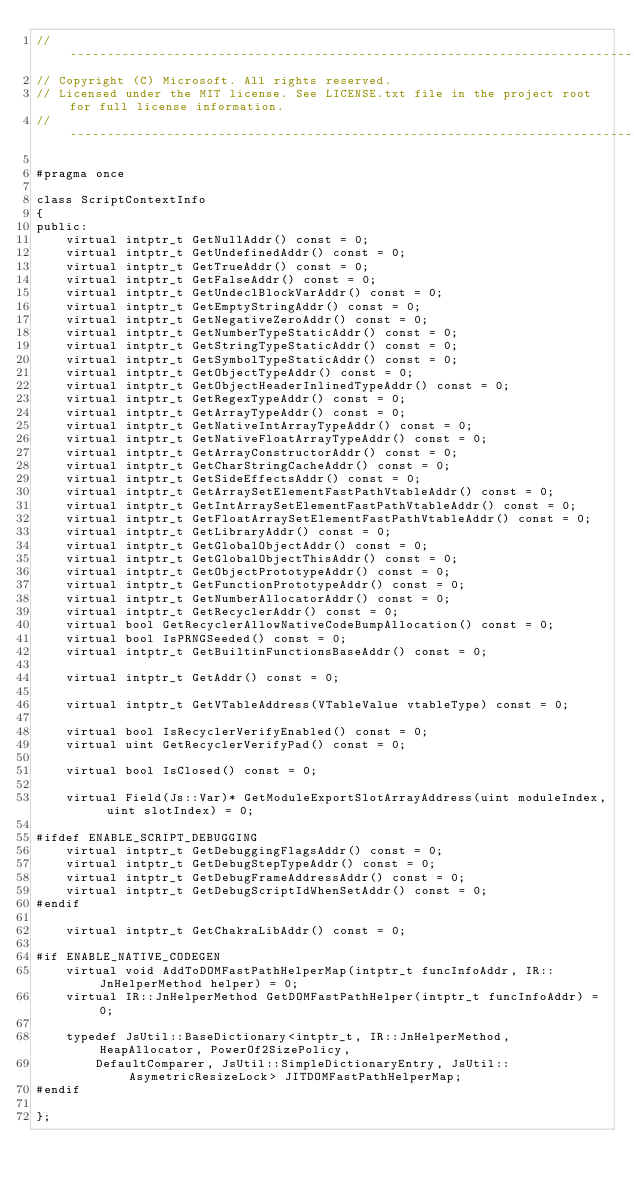Convert code to text. <code><loc_0><loc_0><loc_500><loc_500><_C_>//-------------------------------------------------------------------------------------------------------
// Copyright (C) Microsoft. All rights reserved.
// Licensed under the MIT license. See LICENSE.txt file in the project root for full license information.
//-------------------------------------------------------------------------------------------------------

#pragma once

class ScriptContextInfo
{
public:
    virtual intptr_t GetNullAddr() const = 0;
    virtual intptr_t GetUndefinedAddr() const = 0;
    virtual intptr_t GetTrueAddr() const = 0;
    virtual intptr_t GetFalseAddr() const = 0;
    virtual intptr_t GetUndeclBlockVarAddr() const = 0;
    virtual intptr_t GetEmptyStringAddr() const = 0;
    virtual intptr_t GetNegativeZeroAddr() const = 0;
    virtual intptr_t GetNumberTypeStaticAddr() const = 0;
    virtual intptr_t GetStringTypeStaticAddr() const = 0;
    virtual intptr_t GetSymbolTypeStaticAddr() const = 0;
    virtual intptr_t GetObjectTypeAddr() const = 0;
    virtual intptr_t GetObjectHeaderInlinedTypeAddr() const = 0;
    virtual intptr_t GetRegexTypeAddr() const = 0;
    virtual intptr_t GetArrayTypeAddr() const = 0;
    virtual intptr_t GetNativeIntArrayTypeAddr() const = 0;
    virtual intptr_t GetNativeFloatArrayTypeAddr() const = 0;
    virtual intptr_t GetArrayConstructorAddr() const = 0;
    virtual intptr_t GetCharStringCacheAddr() const = 0;
    virtual intptr_t GetSideEffectsAddr() const = 0;
    virtual intptr_t GetArraySetElementFastPathVtableAddr() const = 0;
    virtual intptr_t GetIntArraySetElementFastPathVtableAddr() const = 0;
    virtual intptr_t GetFloatArraySetElementFastPathVtableAddr() const = 0;
    virtual intptr_t GetLibraryAddr() const = 0;
    virtual intptr_t GetGlobalObjectAddr() const = 0;
    virtual intptr_t GetGlobalObjectThisAddr() const = 0;
    virtual intptr_t GetObjectPrototypeAddr() const = 0;
    virtual intptr_t GetFunctionPrototypeAddr() const = 0;
    virtual intptr_t GetNumberAllocatorAddr() const = 0;
    virtual intptr_t GetRecyclerAddr() const = 0;
    virtual bool GetRecyclerAllowNativeCodeBumpAllocation() const = 0;
    virtual bool IsPRNGSeeded() const = 0;
    virtual intptr_t GetBuiltinFunctionsBaseAddr() const = 0;

    virtual intptr_t GetAddr() const = 0;

    virtual intptr_t GetVTableAddress(VTableValue vtableType) const = 0;

    virtual bool IsRecyclerVerifyEnabled() const = 0;
    virtual uint GetRecyclerVerifyPad() const = 0;

    virtual bool IsClosed() const = 0;

    virtual Field(Js::Var)* GetModuleExportSlotArrayAddress(uint moduleIndex, uint slotIndex) = 0;

#ifdef ENABLE_SCRIPT_DEBUGGING
    virtual intptr_t GetDebuggingFlagsAddr() const = 0;
    virtual intptr_t GetDebugStepTypeAddr() const = 0;
    virtual intptr_t GetDebugFrameAddressAddr() const = 0;
    virtual intptr_t GetDebugScriptIdWhenSetAddr() const = 0;
#endif

    virtual intptr_t GetChakraLibAddr() const = 0;

#if ENABLE_NATIVE_CODEGEN
    virtual void AddToDOMFastPathHelperMap(intptr_t funcInfoAddr, IR::JnHelperMethod helper) = 0;
    virtual IR::JnHelperMethod GetDOMFastPathHelper(intptr_t funcInfoAddr) = 0;

    typedef JsUtil::BaseDictionary<intptr_t, IR::JnHelperMethod, HeapAllocator, PowerOf2SizePolicy,
        DefaultComparer, JsUtil::SimpleDictionaryEntry, JsUtil::AsymetricResizeLock> JITDOMFastPathHelperMap;
#endif

};
</code> 